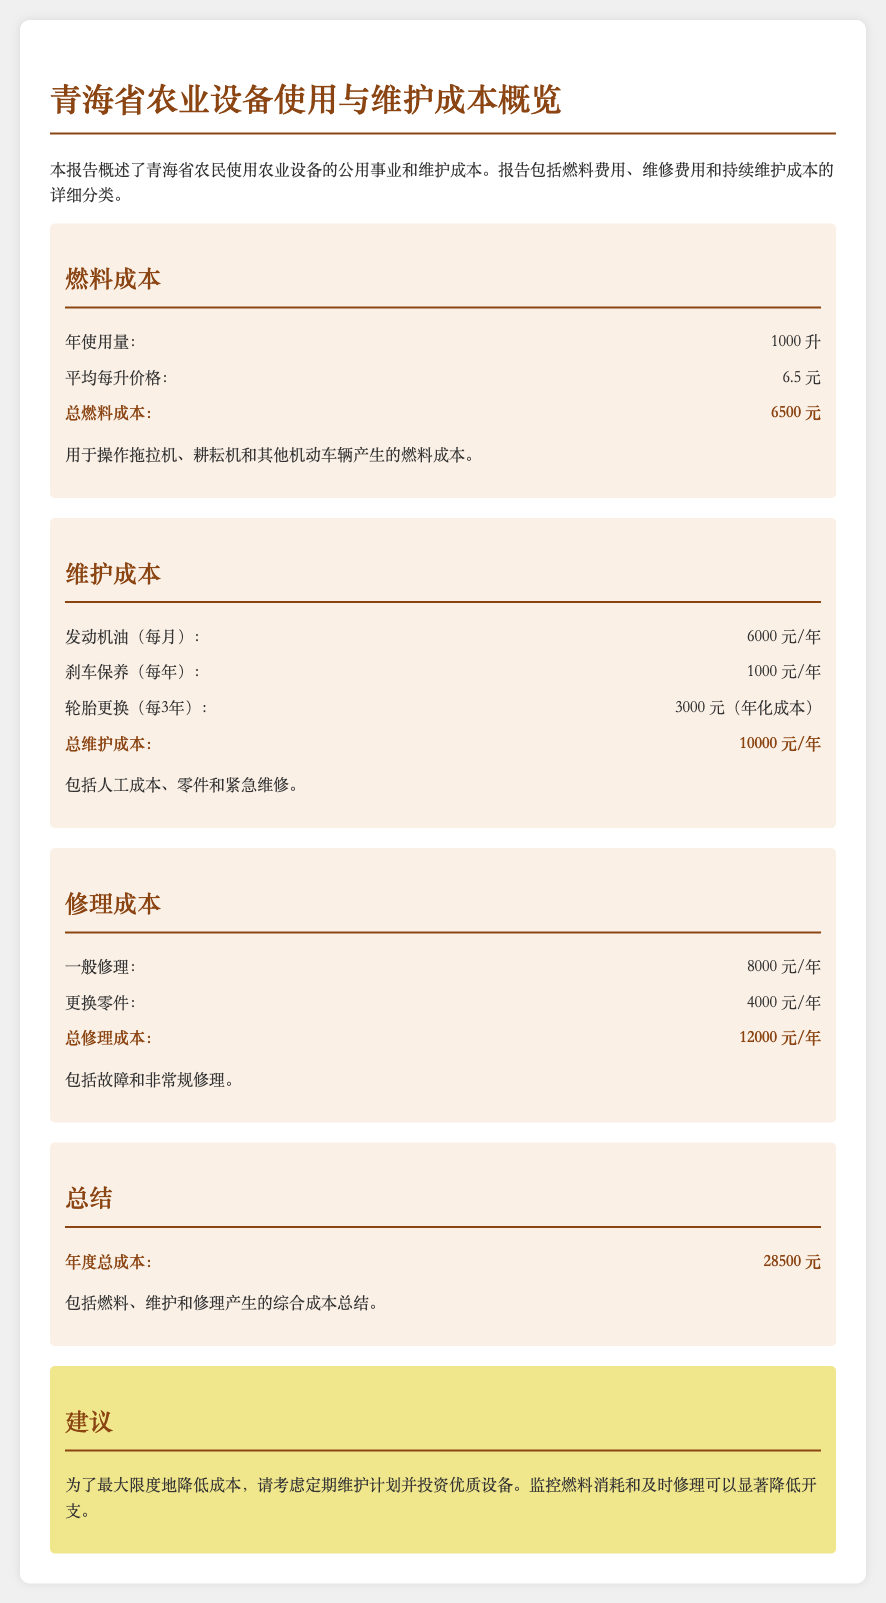年使用量是多少？ 年使用量指的是在一年内农民使用的燃料总量，这里给出的数字是1000升。
Answer: 1000升 总燃料成本是多少？ 总燃料成本是通过年使用量和每升价格计算得出的结果，结果为6500元。
Answer: 6500元 年度总成本是多少？ 年度总成本是所有费用的综合总和，文中提到的总成本为28500元。
Answer: 28500元 每年轮胎更换的年化成本是多少？ 轮胎更换的成本经过分摊计算后得出年化成本，总金额为3000元。
Answer: 3000元 总修理成本是多少？ 总修理成本是一般修理和更换零件费用的总和，结果为12000元。
Answer: 12000元 平均每升燃料价格是多少？ 文中提到的平均每升燃料价格为6.5元。
Answer: 6.5元 建议的核心内容是什么？ 建议包括定期维护、投资优质设备，监控燃料消耗和及时修理。
Answer: 定期维护计划 每年发动机油的费用是多少？ 每年发动机油的费用为6000元。
Answer: 6000元 维护成本的总数是多少？ 维护成本的总和为10000元。
Answer: 10000元 